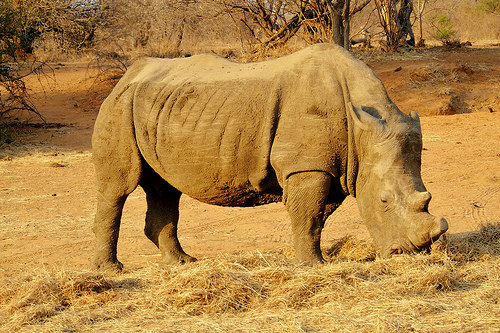<image>
Is the tree behind the rhinoceros? Yes. From this viewpoint, the tree is positioned behind the rhinoceros, with the rhinoceros partially or fully occluding the tree. Is there a rhino in front of the ground? No. The rhino is not in front of the ground. The spatial positioning shows a different relationship between these objects. 